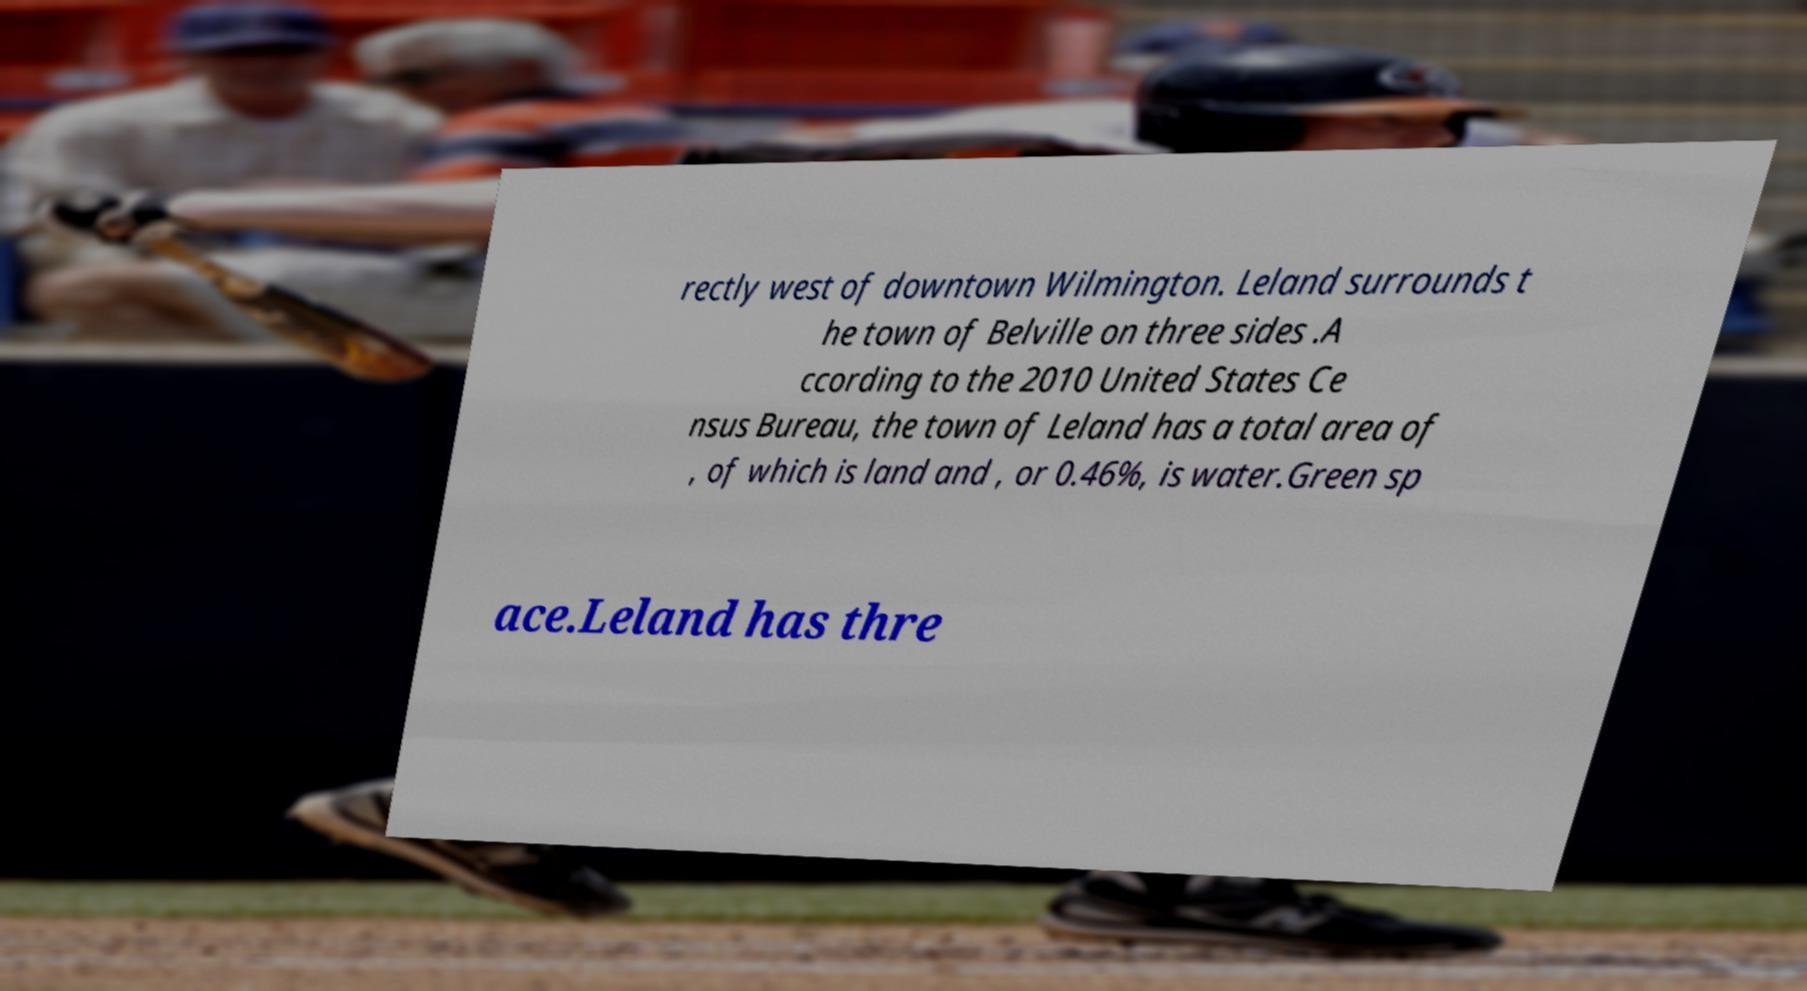Could you extract and type out the text from this image? rectly west of downtown Wilmington. Leland surrounds t he town of Belville on three sides .A ccording to the 2010 United States Ce nsus Bureau, the town of Leland has a total area of , of which is land and , or 0.46%, is water.Green sp ace.Leland has thre 